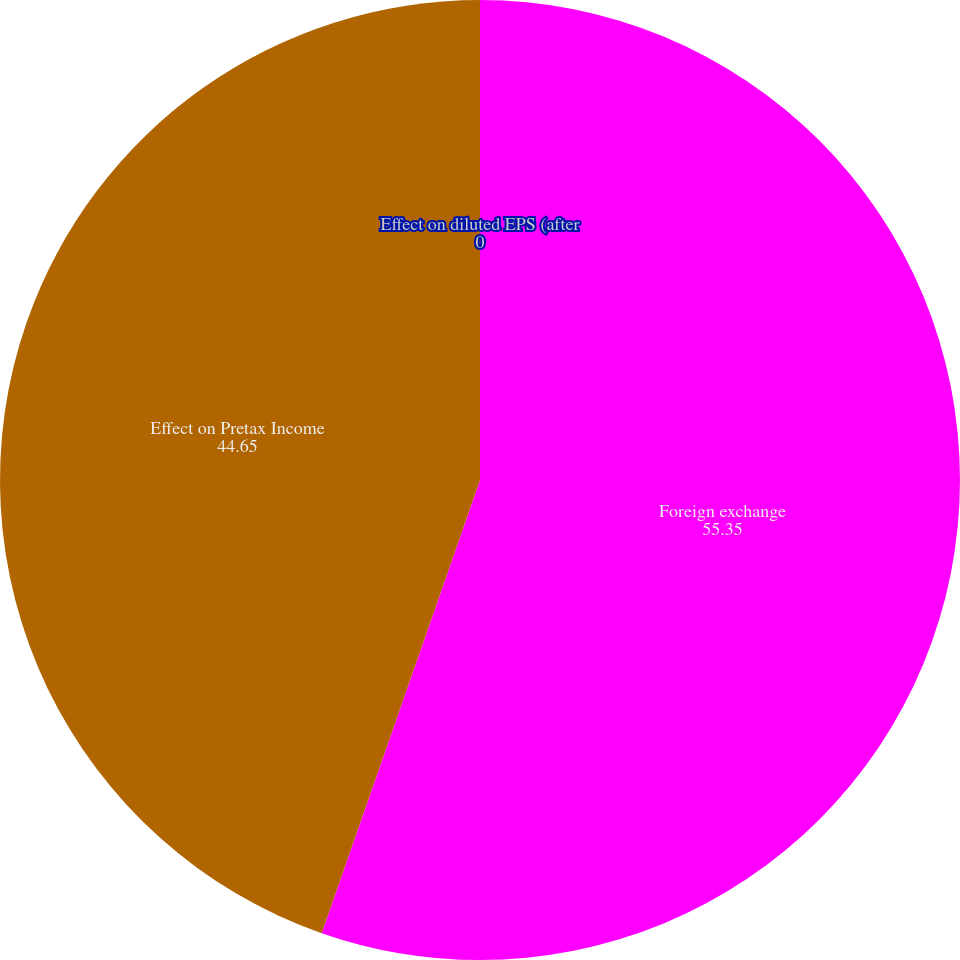<chart> <loc_0><loc_0><loc_500><loc_500><pie_chart><fcel>Foreign exchange<fcel>Effect on Pretax Income<fcel>Effect on diluted EPS (after<nl><fcel>55.35%<fcel>44.65%<fcel>0.0%<nl></chart> 